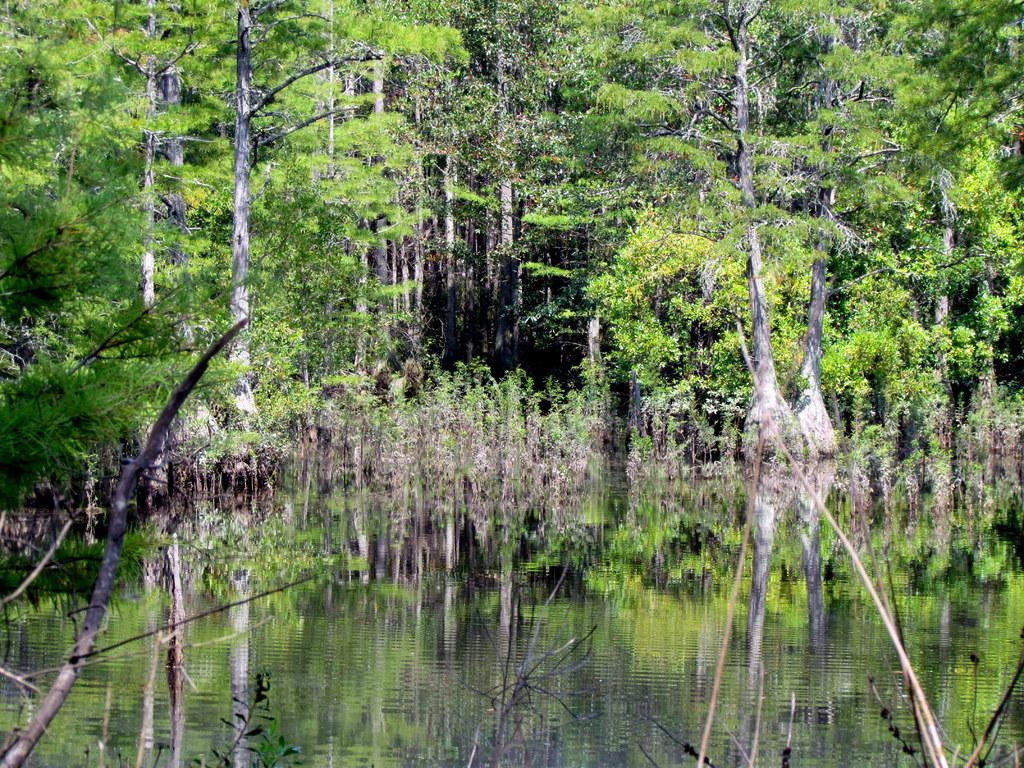What type of vegetation can be seen in the image? There are trees and plants in the image. What natural element is visible in the image? There is water visible in the image. How many boats are visible in the image? There are no boats present in the image. Are there any dinosaurs visible in the image? There are no dinosaurs present in the image. 